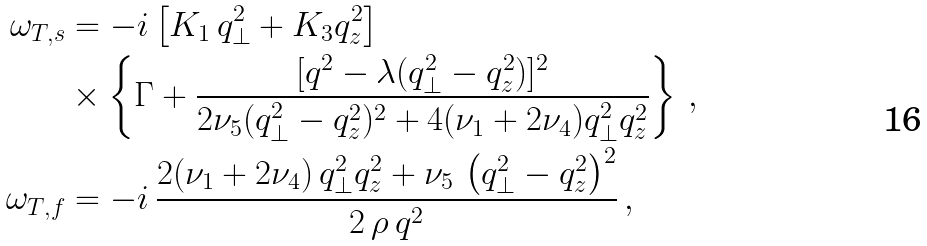Convert formula to latex. <formula><loc_0><loc_0><loc_500><loc_500>\omega _ { T , s } & = - i \left [ K _ { 1 } \, q _ { \perp } ^ { 2 } + K _ { 3 } q _ { z } ^ { 2 } \right ] \\ & \times \left \{ \Gamma + \frac { [ q ^ { 2 } - \lambda ( q _ { \perp } ^ { 2 } - q _ { z } ^ { 2 } ) ] ^ { 2 } } { 2 \nu _ { 5 } ( q _ { \perp } ^ { 2 } - q _ { z } ^ { 2 } ) ^ { 2 } + 4 ( \nu _ { 1 } + 2 \nu _ { 4 } ) q _ { \perp } ^ { 2 } q _ { z } ^ { 2 } } \right \} \, , \\ \omega _ { T , f } & = - i \, \frac { 2 ( \nu _ { 1 } + 2 \nu _ { 4 } ) \, q _ { \perp } ^ { 2 } q _ { z } ^ { 2 } + \nu _ { 5 } \, \left ( q _ { \perp } ^ { 2 } - q _ { z } ^ { 2 } \right ) ^ { 2 } } { 2 \, \rho \, q ^ { 2 } } \, ,</formula> 